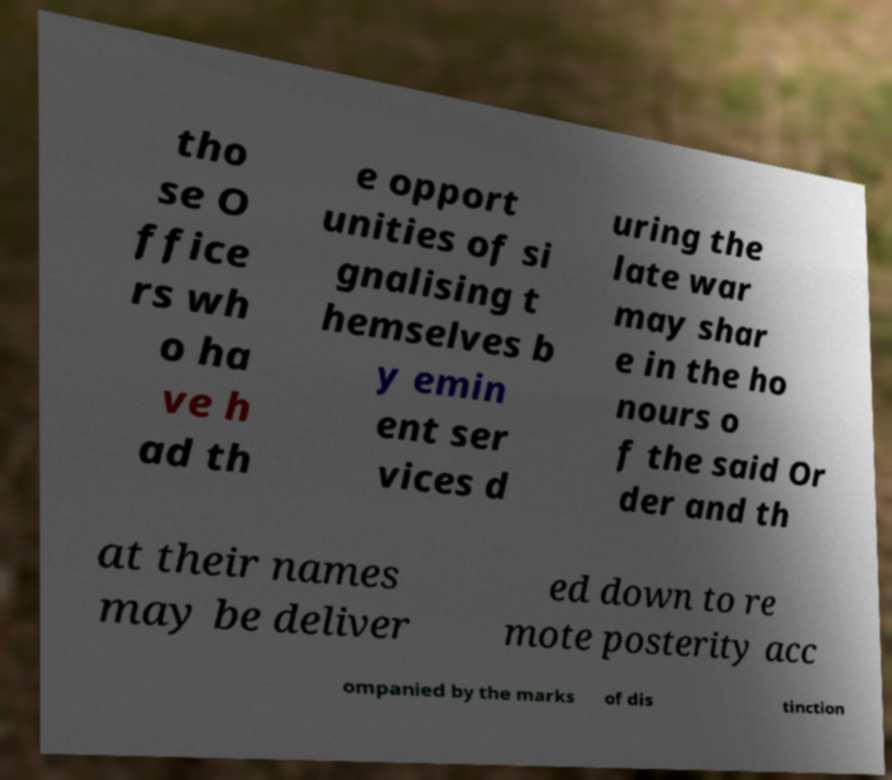Please identify and transcribe the text found in this image. tho se O ffice rs wh o ha ve h ad th e opport unities of si gnalising t hemselves b y emin ent ser vices d uring the late war may shar e in the ho nours o f the said Or der and th at their names may be deliver ed down to re mote posterity acc ompanied by the marks of dis tinction 